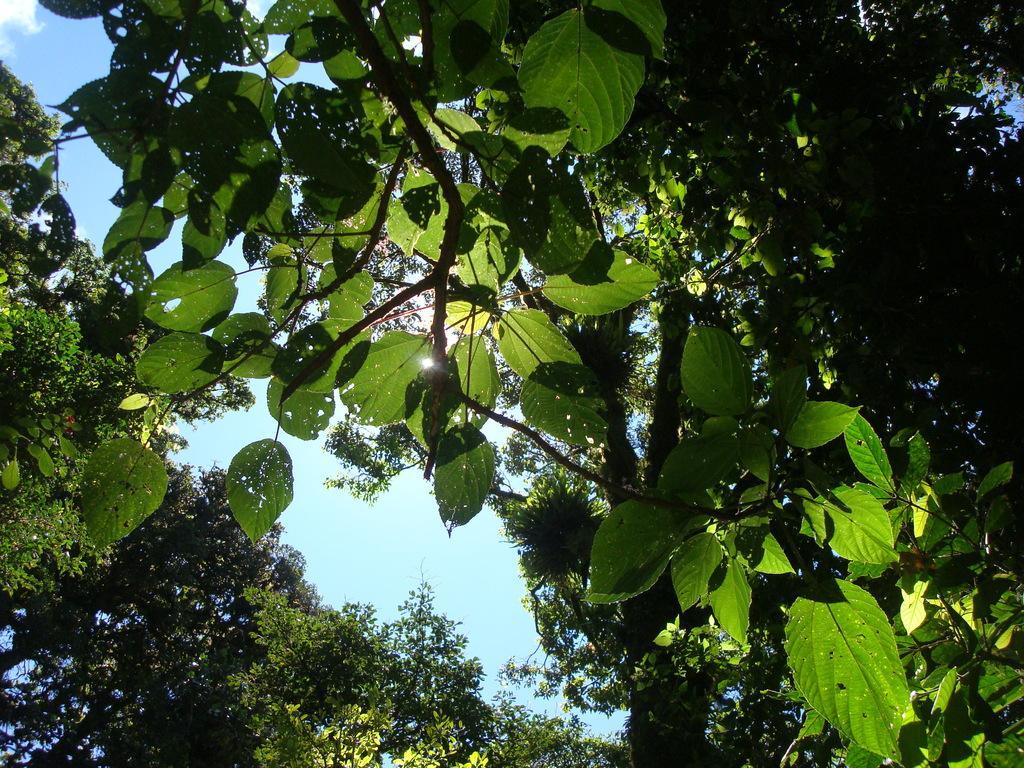In one or two sentences, can you explain what this image depicts? In this picture there are few trees and the sky is in blue color. 